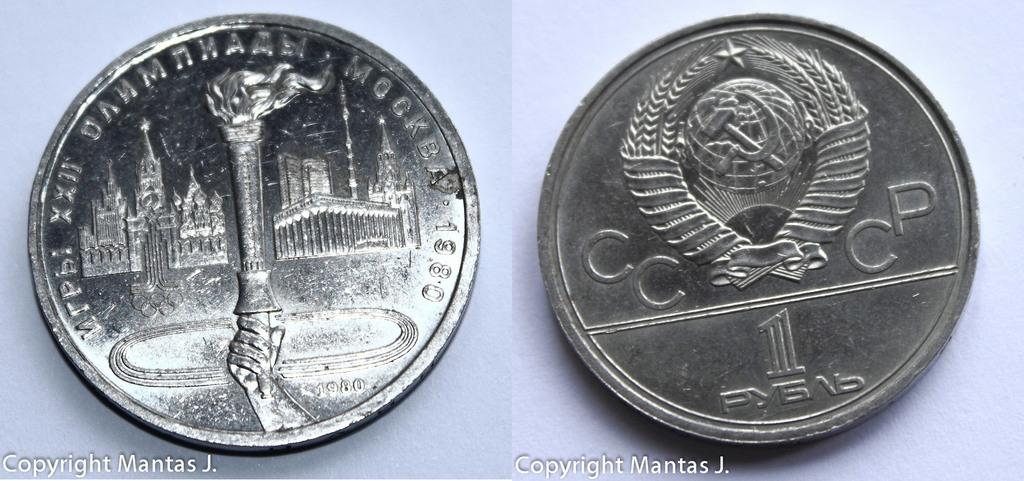<image>
Render a clear and concise summary of the photo. Two sides of one coin with a one on one side and 22 in Roman numerals on the other side. 